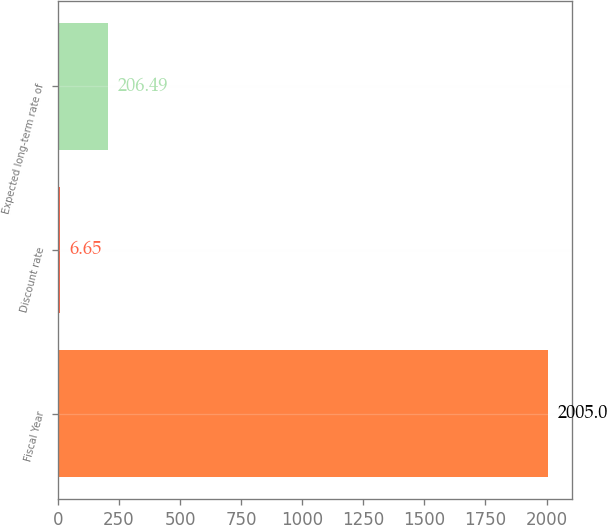Convert chart. <chart><loc_0><loc_0><loc_500><loc_500><bar_chart><fcel>Fiscal Year<fcel>Discount rate<fcel>Expected long-term rate of<nl><fcel>2005<fcel>6.65<fcel>206.49<nl></chart> 